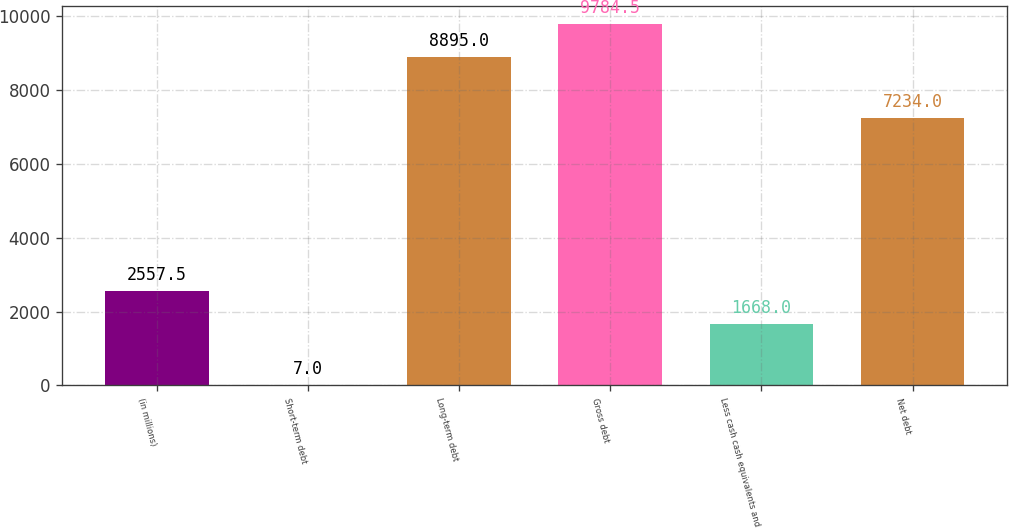Convert chart. <chart><loc_0><loc_0><loc_500><loc_500><bar_chart><fcel>(in millions)<fcel>Short-term debt<fcel>Long-term debt<fcel>Gross debt<fcel>Less cash cash equivalents and<fcel>Net debt<nl><fcel>2557.5<fcel>7<fcel>8895<fcel>9784.5<fcel>1668<fcel>7234<nl></chart> 